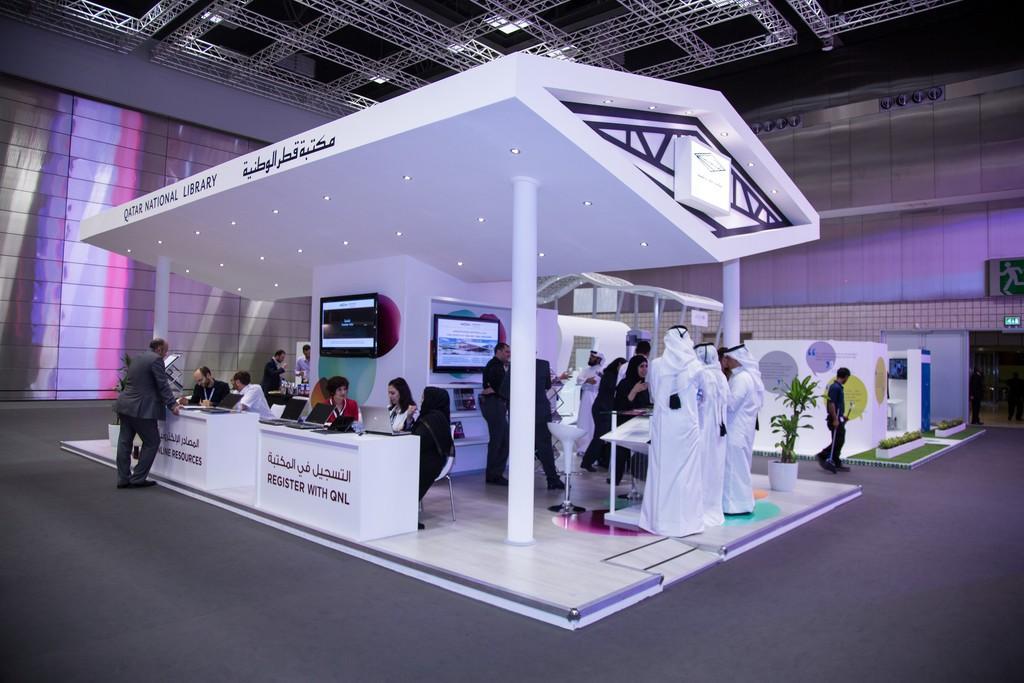Please provide a concise description of this image. This image is taken indoors. At the bottom of the image there is a floor. In the background there are a few walls. There is a door. There is a sign board. At the top of the image there is a roof with a few lights and there are many iron bars. In the middle of the image there is a stall with a roof, walls and pillars. There is a text on the wall. There are two televisions. There are two tables with a few things on them. There are two boards with text on them. A few people are standing on the floor and a few are sitting in the chairs. There is a plant in the pot. A man is walking on the floor. 